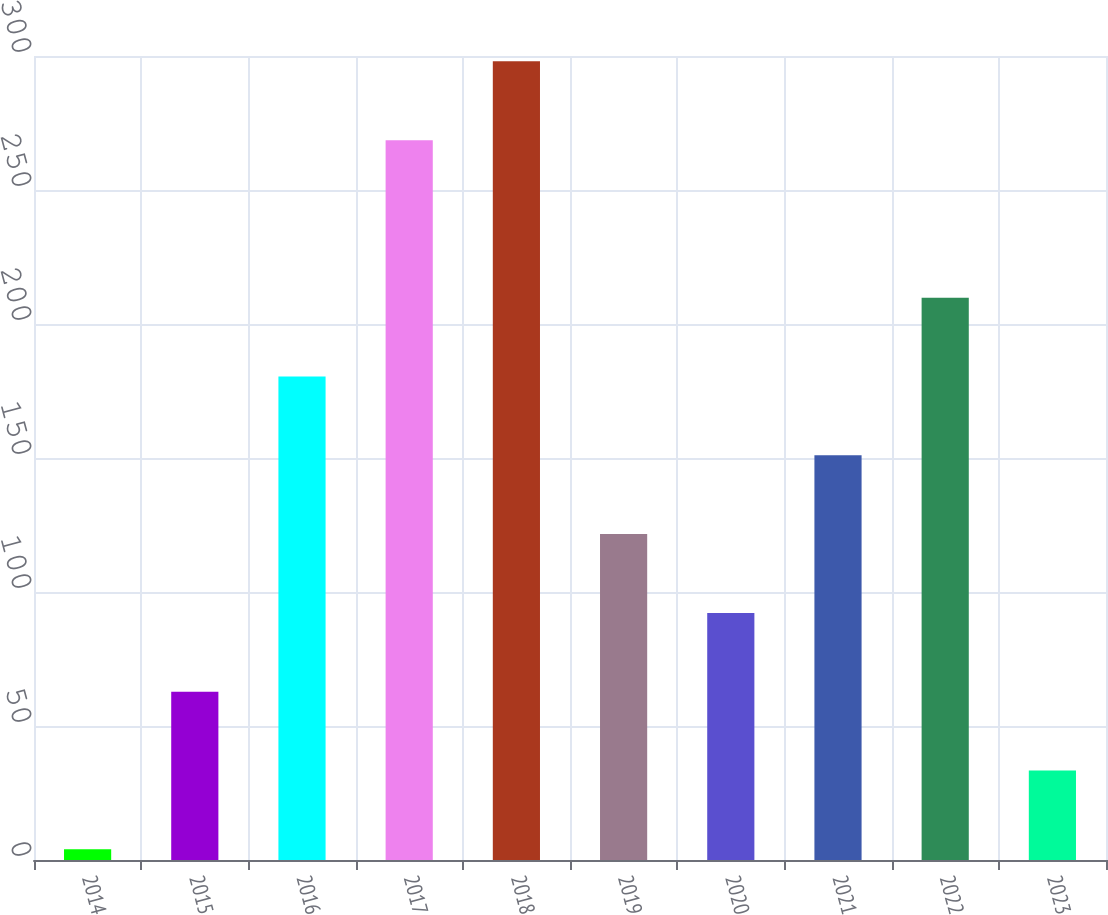Convert chart to OTSL. <chart><loc_0><loc_0><loc_500><loc_500><bar_chart><fcel>2014<fcel>2015<fcel>2016<fcel>2017<fcel>2018<fcel>2019<fcel>2020<fcel>2021<fcel>2022<fcel>2023<nl><fcel>4<fcel>62.8<fcel>180.4<fcel>268.6<fcel>298<fcel>121.6<fcel>92.2<fcel>151<fcel>209.8<fcel>33.4<nl></chart> 